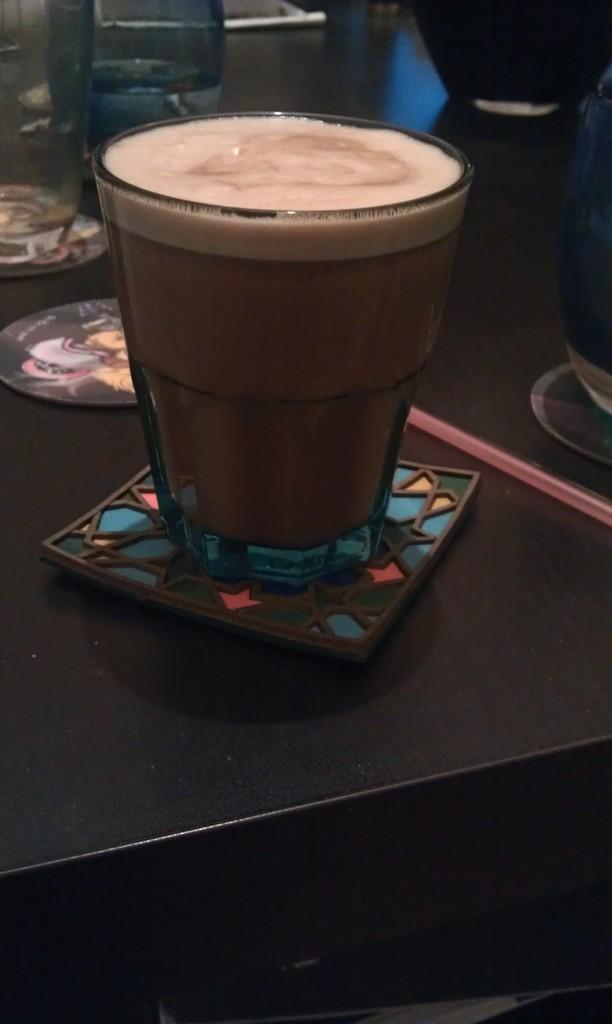Describe this image in one or two sentences. In this picture we can see a glass with a drink in it on a table and in the background we can see some objects. 